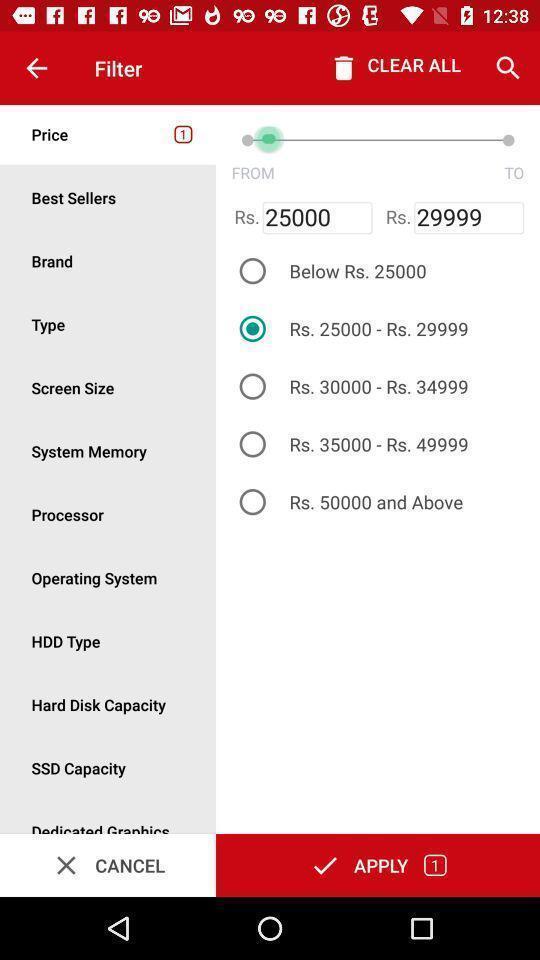What can you discern from this picture? Screen displaying the filter page. 